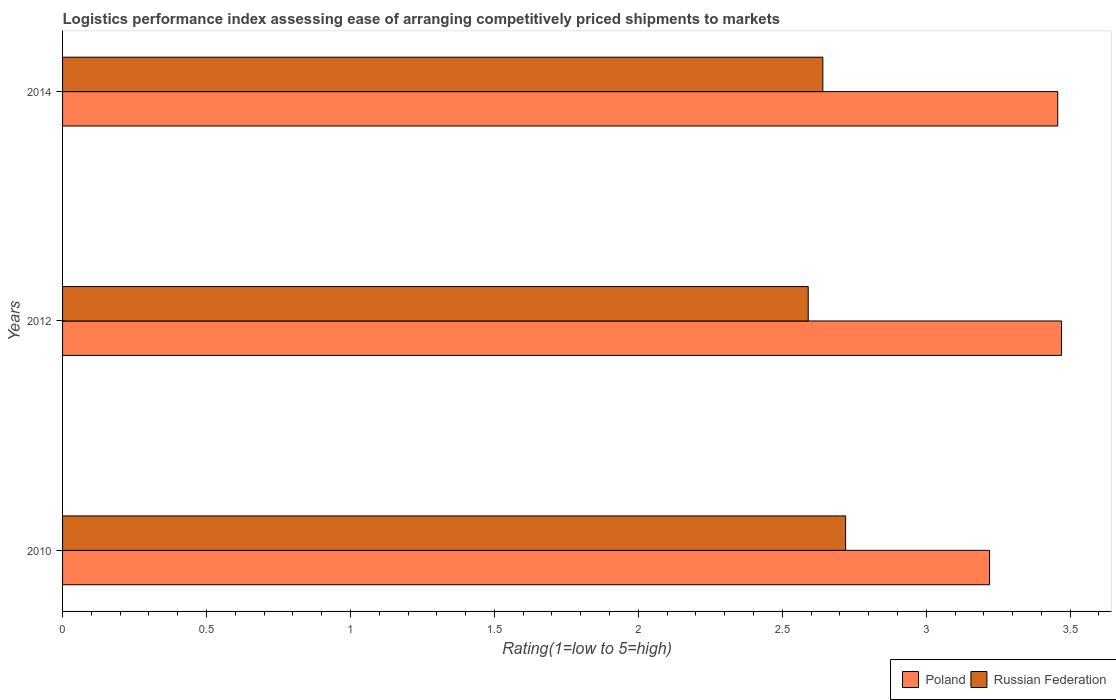How many different coloured bars are there?
Keep it short and to the point. 2. Are the number of bars on each tick of the Y-axis equal?
Make the answer very short. Yes. How many bars are there on the 2nd tick from the bottom?
Provide a succinct answer. 2. What is the label of the 1st group of bars from the top?
Your answer should be very brief. 2014. What is the Logistic performance index in Poland in 2014?
Give a very brief answer. 3.46. Across all years, what is the maximum Logistic performance index in Poland?
Provide a short and direct response. 3.47. Across all years, what is the minimum Logistic performance index in Russian Federation?
Offer a very short reply. 2.59. In which year was the Logistic performance index in Poland maximum?
Your response must be concise. 2012. In which year was the Logistic performance index in Russian Federation minimum?
Offer a terse response. 2012. What is the total Logistic performance index in Russian Federation in the graph?
Your answer should be compact. 7.95. What is the difference between the Logistic performance index in Russian Federation in 2012 and that in 2014?
Keep it short and to the point. -0.05. What is the difference between the Logistic performance index in Poland in 2010 and the Logistic performance index in Russian Federation in 2014?
Give a very brief answer. 0.58. What is the average Logistic performance index in Poland per year?
Your answer should be very brief. 3.38. In the year 2012, what is the difference between the Logistic performance index in Russian Federation and Logistic performance index in Poland?
Keep it short and to the point. -0.88. In how many years, is the Logistic performance index in Russian Federation greater than 0.4 ?
Give a very brief answer. 3. What is the ratio of the Logistic performance index in Russian Federation in 2010 to that in 2014?
Your answer should be compact. 1.03. Is the Logistic performance index in Russian Federation in 2012 less than that in 2014?
Make the answer very short. Yes. Is the difference between the Logistic performance index in Russian Federation in 2010 and 2014 greater than the difference between the Logistic performance index in Poland in 2010 and 2014?
Ensure brevity in your answer.  Yes. What is the difference between the highest and the second highest Logistic performance index in Poland?
Keep it short and to the point. 0.01. What is the difference between the highest and the lowest Logistic performance index in Poland?
Offer a very short reply. 0.25. What does the 2nd bar from the bottom in 2012 represents?
Keep it short and to the point. Russian Federation. What is the difference between two consecutive major ticks on the X-axis?
Ensure brevity in your answer.  0.5. Does the graph contain grids?
Give a very brief answer. No. How many legend labels are there?
Give a very brief answer. 2. What is the title of the graph?
Your answer should be very brief. Logistics performance index assessing ease of arranging competitively priced shipments to markets. Does "Senegal" appear as one of the legend labels in the graph?
Provide a short and direct response. No. What is the label or title of the X-axis?
Provide a succinct answer. Rating(1=low to 5=high). What is the Rating(1=low to 5=high) in Poland in 2010?
Ensure brevity in your answer.  3.22. What is the Rating(1=low to 5=high) of Russian Federation in 2010?
Ensure brevity in your answer.  2.72. What is the Rating(1=low to 5=high) in Poland in 2012?
Ensure brevity in your answer.  3.47. What is the Rating(1=low to 5=high) of Russian Federation in 2012?
Make the answer very short. 2.59. What is the Rating(1=low to 5=high) of Poland in 2014?
Your answer should be compact. 3.46. What is the Rating(1=low to 5=high) in Russian Federation in 2014?
Your answer should be very brief. 2.64. Across all years, what is the maximum Rating(1=low to 5=high) of Poland?
Your answer should be compact. 3.47. Across all years, what is the maximum Rating(1=low to 5=high) of Russian Federation?
Your answer should be compact. 2.72. Across all years, what is the minimum Rating(1=low to 5=high) of Poland?
Provide a short and direct response. 3.22. Across all years, what is the minimum Rating(1=low to 5=high) in Russian Federation?
Keep it short and to the point. 2.59. What is the total Rating(1=low to 5=high) in Poland in the graph?
Your response must be concise. 10.15. What is the total Rating(1=low to 5=high) of Russian Federation in the graph?
Your response must be concise. 7.95. What is the difference between the Rating(1=low to 5=high) of Poland in 2010 and that in 2012?
Your answer should be very brief. -0.25. What is the difference between the Rating(1=low to 5=high) in Russian Federation in 2010 and that in 2012?
Give a very brief answer. 0.13. What is the difference between the Rating(1=low to 5=high) in Poland in 2010 and that in 2014?
Keep it short and to the point. -0.24. What is the difference between the Rating(1=low to 5=high) in Russian Federation in 2010 and that in 2014?
Offer a terse response. 0.08. What is the difference between the Rating(1=low to 5=high) of Poland in 2012 and that in 2014?
Make the answer very short. 0.01. What is the difference between the Rating(1=low to 5=high) of Russian Federation in 2012 and that in 2014?
Ensure brevity in your answer.  -0.05. What is the difference between the Rating(1=low to 5=high) in Poland in 2010 and the Rating(1=low to 5=high) in Russian Federation in 2012?
Ensure brevity in your answer.  0.63. What is the difference between the Rating(1=low to 5=high) of Poland in 2010 and the Rating(1=low to 5=high) of Russian Federation in 2014?
Provide a succinct answer. 0.58. What is the difference between the Rating(1=low to 5=high) in Poland in 2012 and the Rating(1=low to 5=high) in Russian Federation in 2014?
Your response must be concise. 0.83. What is the average Rating(1=low to 5=high) of Poland per year?
Offer a terse response. 3.38. What is the average Rating(1=low to 5=high) in Russian Federation per year?
Your response must be concise. 2.65. In the year 2012, what is the difference between the Rating(1=low to 5=high) in Poland and Rating(1=low to 5=high) in Russian Federation?
Offer a terse response. 0.88. In the year 2014, what is the difference between the Rating(1=low to 5=high) of Poland and Rating(1=low to 5=high) of Russian Federation?
Offer a terse response. 0.82. What is the ratio of the Rating(1=low to 5=high) in Poland in 2010 to that in 2012?
Offer a terse response. 0.93. What is the ratio of the Rating(1=low to 5=high) of Russian Federation in 2010 to that in 2012?
Keep it short and to the point. 1.05. What is the ratio of the Rating(1=low to 5=high) in Poland in 2010 to that in 2014?
Offer a terse response. 0.93. What is the ratio of the Rating(1=low to 5=high) in Russian Federation in 2010 to that in 2014?
Your response must be concise. 1.03. What is the ratio of the Rating(1=low to 5=high) in Poland in 2012 to that in 2014?
Make the answer very short. 1. What is the ratio of the Rating(1=low to 5=high) in Russian Federation in 2012 to that in 2014?
Make the answer very short. 0.98. What is the difference between the highest and the second highest Rating(1=low to 5=high) in Poland?
Your answer should be compact. 0.01. What is the difference between the highest and the second highest Rating(1=low to 5=high) of Russian Federation?
Ensure brevity in your answer.  0.08. What is the difference between the highest and the lowest Rating(1=low to 5=high) in Poland?
Ensure brevity in your answer.  0.25. What is the difference between the highest and the lowest Rating(1=low to 5=high) of Russian Federation?
Your answer should be very brief. 0.13. 